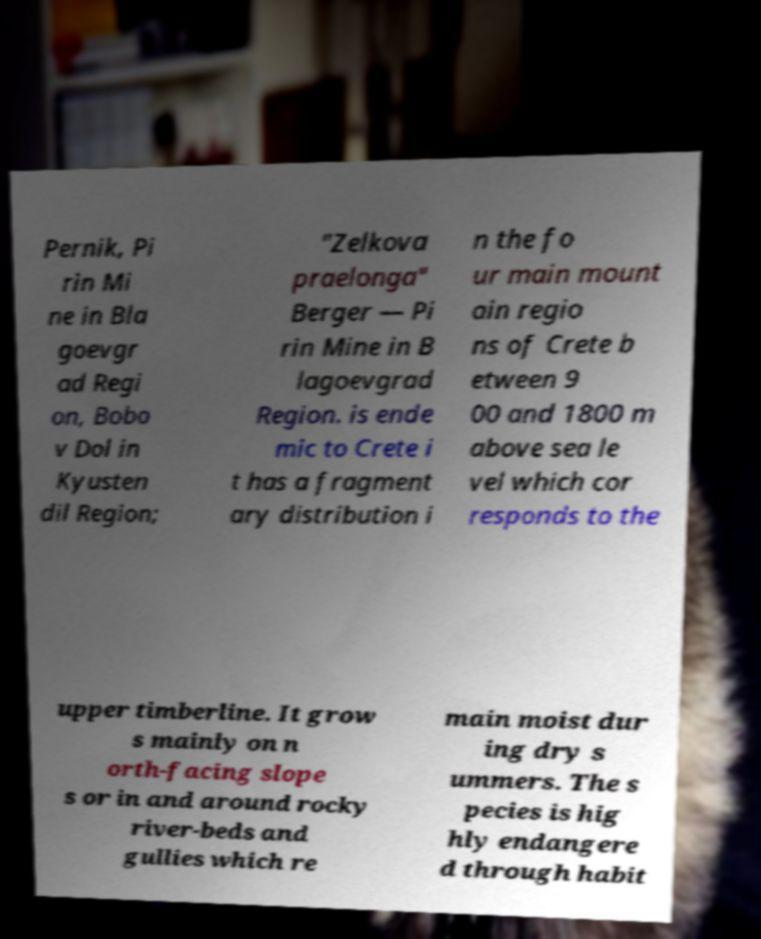There's text embedded in this image that I need extracted. Can you transcribe it verbatim? Pernik, Pi rin Mi ne in Bla goevgr ad Regi on, Bobo v Dol in Kyusten dil Region; "Zelkova praelonga" Berger — Pi rin Mine in B lagoevgrad Region. is ende mic to Crete i t has a fragment ary distribution i n the fo ur main mount ain regio ns of Crete b etween 9 00 and 1800 m above sea le vel which cor responds to the upper timberline. It grow s mainly on n orth-facing slope s or in and around rocky river-beds and gullies which re main moist dur ing dry s ummers. The s pecies is hig hly endangere d through habit 